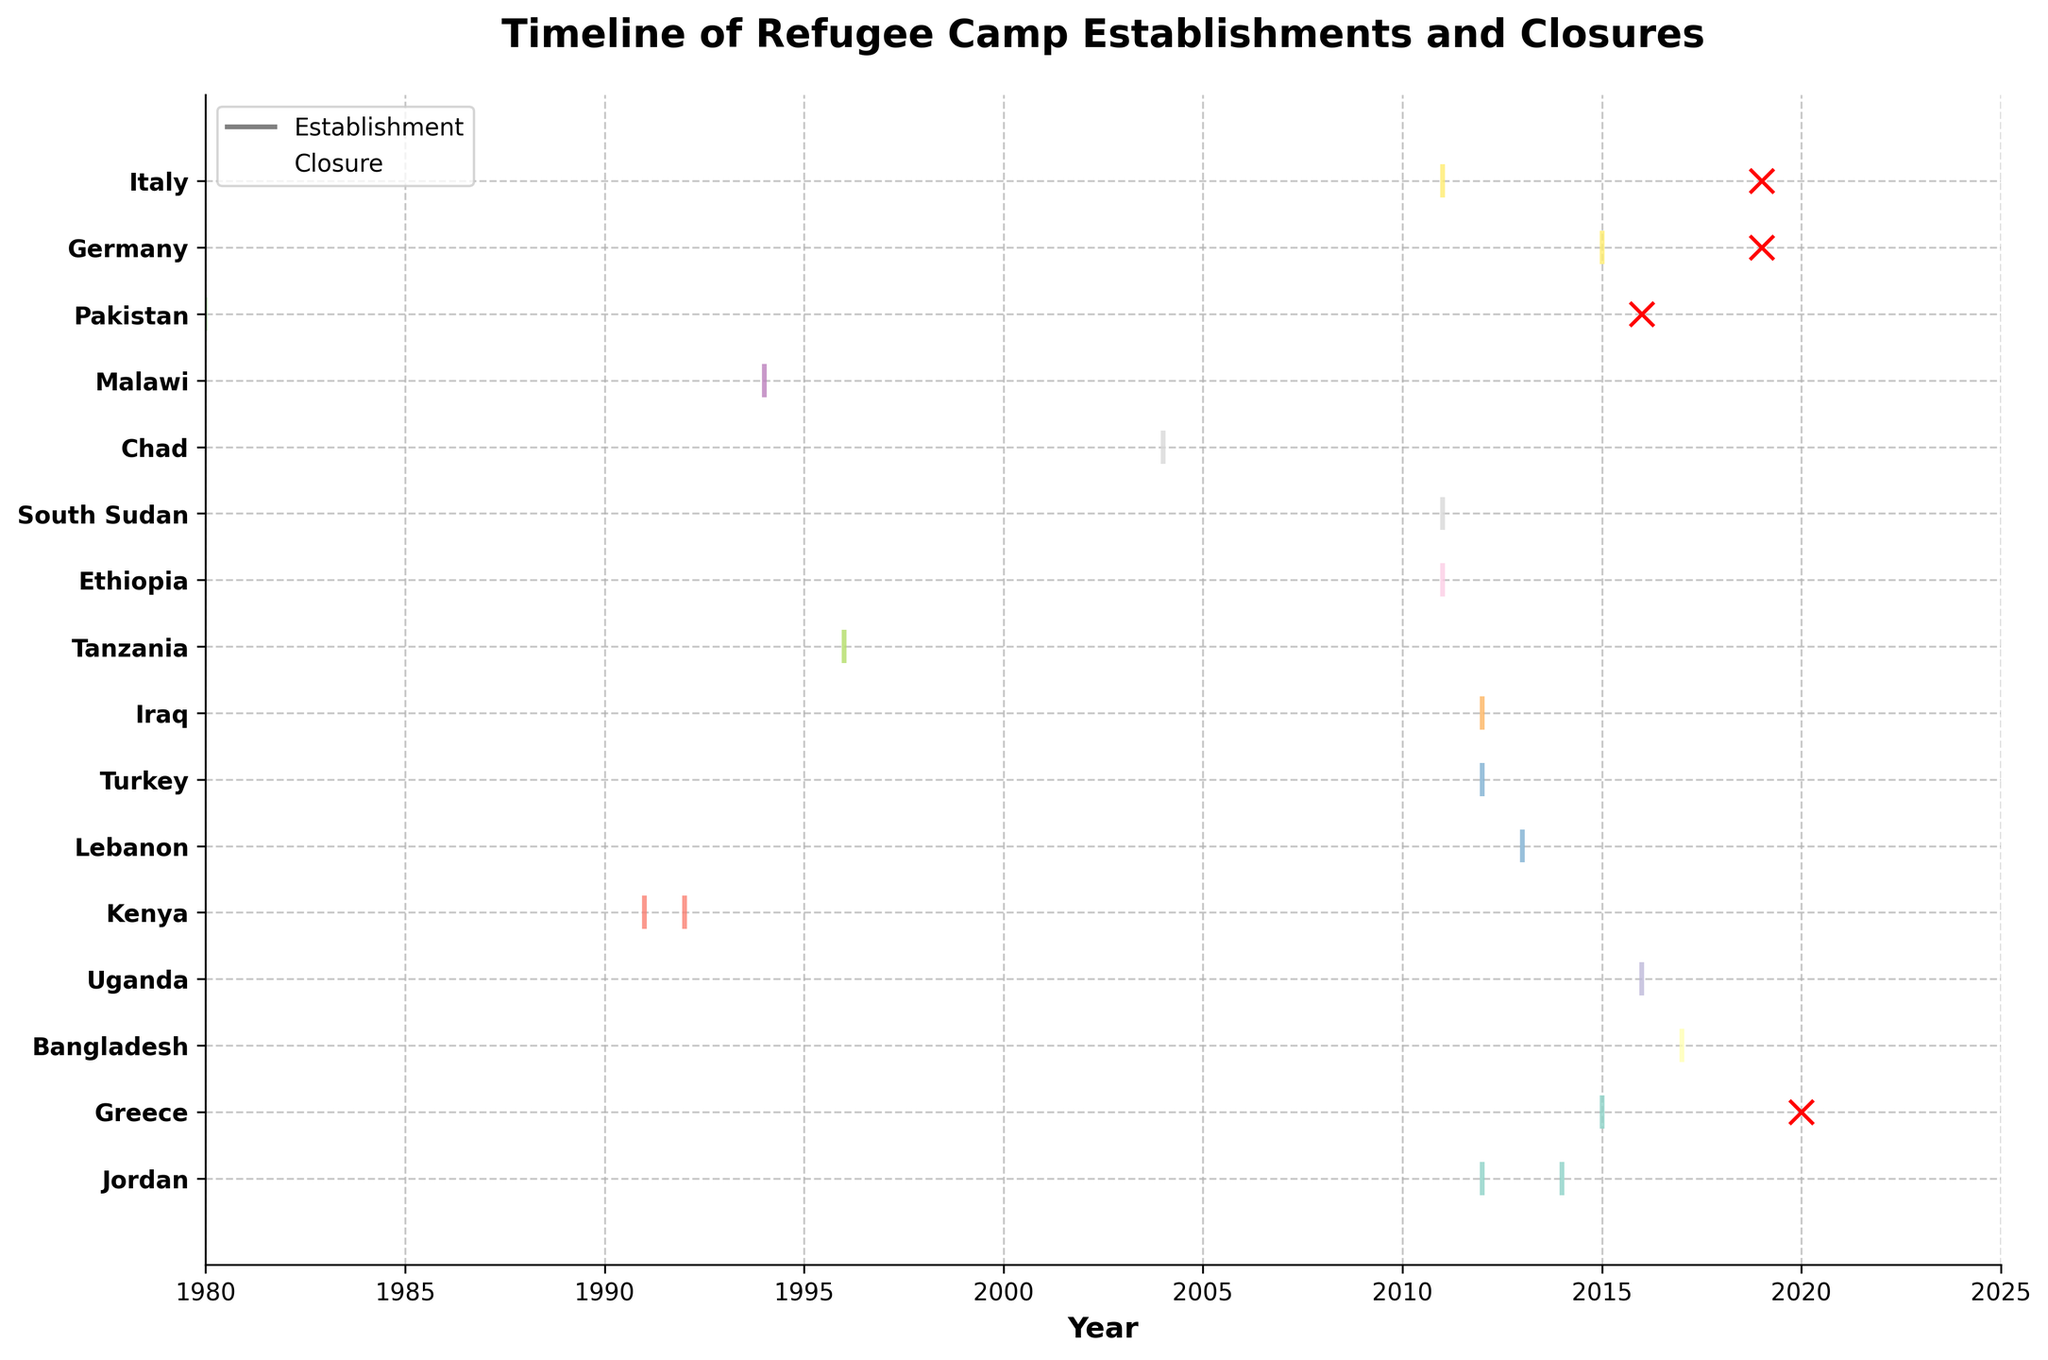Which country has the earliest recorded establishment of a refugee camp based on the timeline? We look for the first establishment event on the timeline. Pakistan's Jalozai camp was established in 1980, which is the earliest.
Answer: Pakistan How many refugee camps were established in Greece? By examining the data points for Greece, we see two establishment events: Moria in 2015 and another camp will not count as the event was closure. Therefore, Greece has one establishment.
Answer: 1 Which country had the most recent refugee camp closure? The figure shows the closure events marked with red 'x'. The most recent closure is for Greece (Moria) in 2020.
Answer: Greece How many countries have both establishment and closure events shown? We need to identify countries that have both lines and red 'x' marks. These countries are Germany, Greece, Italy, and Pakistan. Therefore, four countries have both establishment and closure events.
Answer: 4 Which country has the most refugee camp establishments based on the timeline? By counting the establishment events for each country, Jordan has two establishment events (Zaatari in 2012 and Azraq in 2014), which is the highest count on the timeline.
Answer: Jordan How many refugee camps were closed in 2019? The figure shows events with red 'x' for closures. In 2019, closures are marked for Germany (Tempohomes) and Italy (Mineo). Hence, there are two closures.
Answer: 2 Which countries have refugee camps established between 2010 and 2015? Looking for establishment events within the specified years, we find the following countries: Ethiopia (Dollo Ado in 2011), South Sudan (Yida in 2011), Italy (Mineo in 2011), Turkey (Oncupinar in 2012), Iraq (Domiz in 2012), Jordan (Zaatari in 2012 and Azraq in 2014), Lebanon (Bar Elias in 2013), and Greece (Moria in 2015).
Answer: Ethiopia, South Sudan, Italy, Turkey, Iraq, Jordan, Lebanon, Greece Which country closed a refugee camp in the same year another was established? We look for overlap in the years of establishment and closure events. In 2016, Jordan had Azraq established and Pakistan had Jalozai closed. These are different countries so we find Germany closed Tempohomes and Italy closed Mineo in 2019 after being established earlier. Hence, both are included in the answer.
Answer: Germany, Italy 